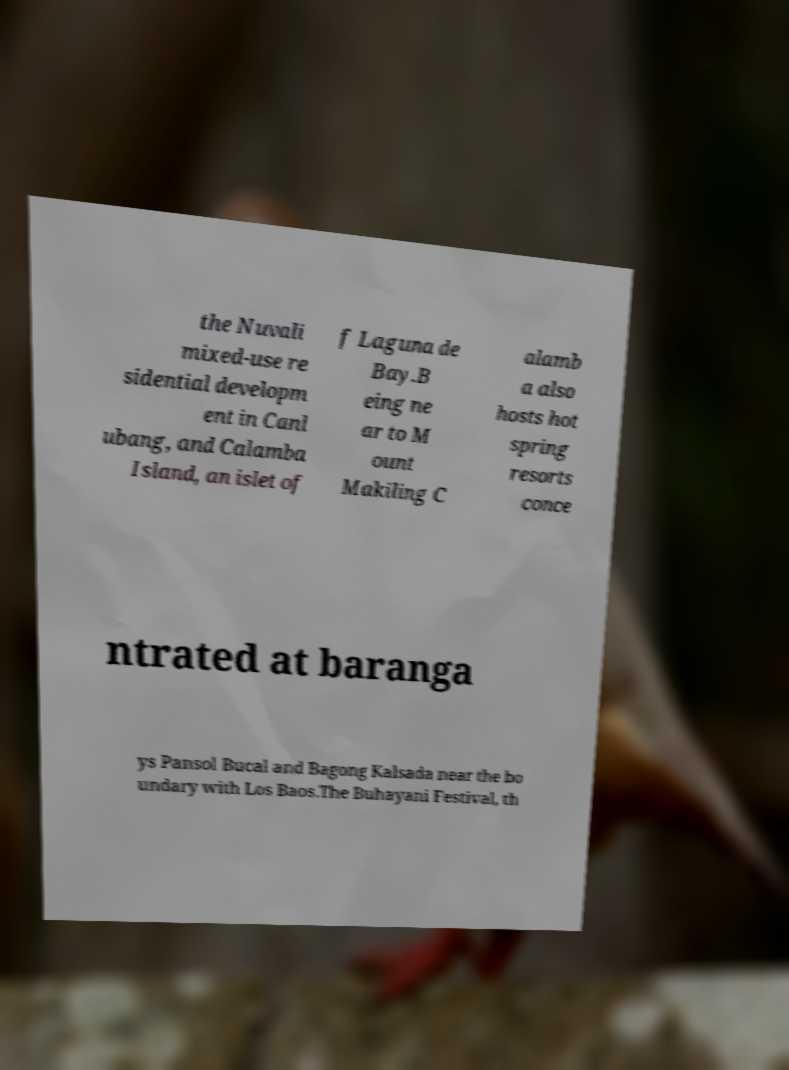I need the written content from this picture converted into text. Can you do that? the Nuvali mixed-use re sidential developm ent in Canl ubang, and Calamba Island, an islet of f Laguna de Bay.B eing ne ar to M ount Makiling C alamb a also hosts hot spring resorts conce ntrated at baranga ys Pansol Bucal and Bagong Kalsada near the bo undary with Los Baos.The Buhayani Festival, th 